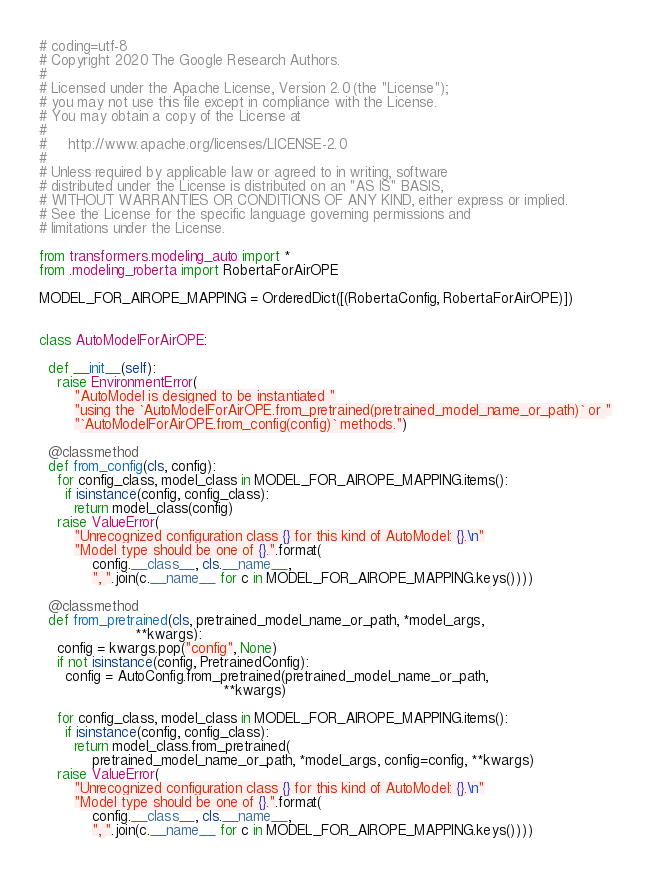Convert code to text. <code><loc_0><loc_0><loc_500><loc_500><_Python_># coding=utf-8
# Copyright 2020 The Google Research Authors.
#
# Licensed under the Apache License, Version 2.0 (the "License");
# you may not use this file except in compliance with the License.
# You may obtain a copy of the License at
#
#     http://www.apache.org/licenses/LICENSE-2.0
#
# Unless required by applicable law or agreed to in writing, software
# distributed under the License is distributed on an "AS IS" BASIS,
# WITHOUT WARRANTIES OR CONDITIONS OF ANY KIND, either express or implied.
# See the License for the specific language governing permissions and
# limitations under the License.

from transformers.modeling_auto import *
from .modeling_roberta import RobertaForAirOPE

MODEL_FOR_AIROPE_MAPPING = OrderedDict([(RobertaConfig, RobertaForAirOPE)])


class AutoModelForAirOPE:

  def __init__(self):
    raise EnvironmentError(
        "AutoModel is designed to be instantiated "
        "using the `AutoModelForAirOPE.from_pretrained(pretrained_model_name_or_path)` or "
        "`AutoModelForAirOPE.from_config(config)` methods.")

  @classmethod
  def from_config(cls, config):
    for config_class, model_class in MODEL_FOR_AIROPE_MAPPING.items():
      if isinstance(config, config_class):
        return model_class(config)
    raise ValueError(
        "Unrecognized configuration class {} for this kind of AutoModel: {}.\n"
        "Model type should be one of {}.".format(
            config.__class__, cls.__name__,
            ", ".join(c.__name__ for c in MODEL_FOR_AIROPE_MAPPING.keys())))

  @classmethod
  def from_pretrained(cls, pretrained_model_name_or_path, *model_args,
                      **kwargs):
    config = kwargs.pop("config", None)
    if not isinstance(config, PretrainedConfig):
      config = AutoConfig.from_pretrained(pretrained_model_name_or_path,
                                          **kwargs)

    for config_class, model_class in MODEL_FOR_AIROPE_MAPPING.items():
      if isinstance(config, config_class):
        return model_class.from_pretrained(
            pretrained_model_name_or_path, *model_args, config=config, **kwargs)
    raise ValueError(
        "Unrecognized configuration class {} for this kind of AutoModel: {}.\n"
        "Model type should be one of {}.".format(
            config.__class__, cls.__name__,
            ", ".join(c.__name__ for c in MODEL_FOR_AIROPE_MAPPING.keys())))
</code> 